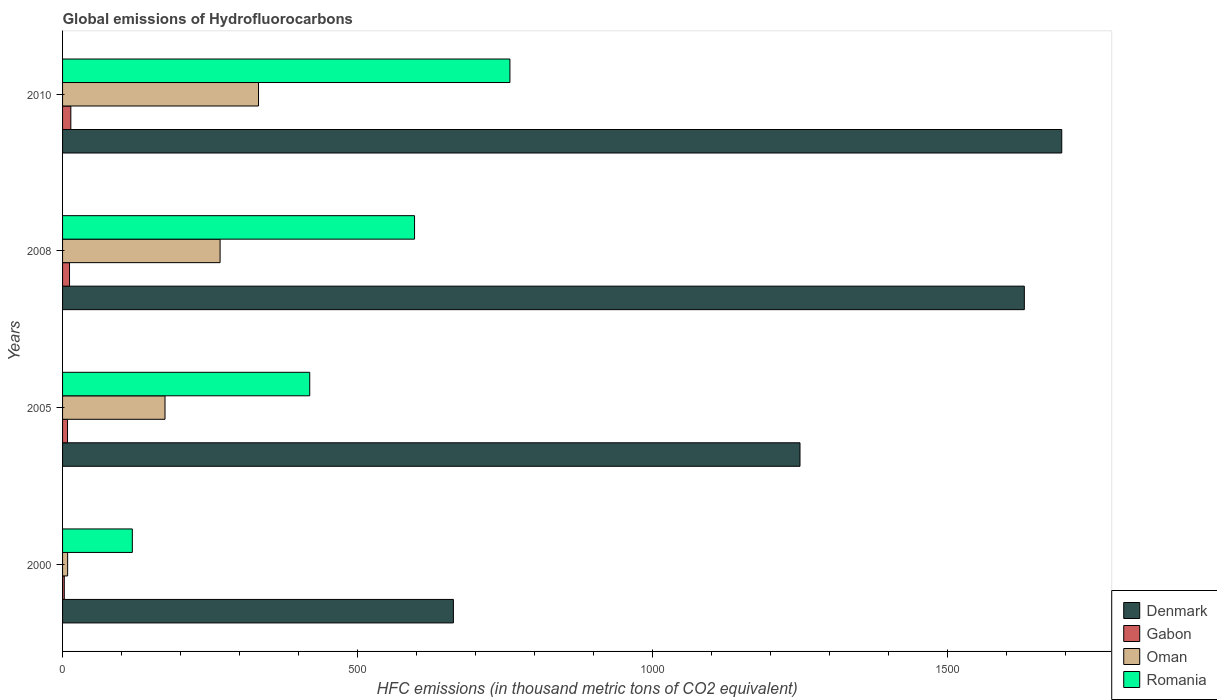Are the number of bars on each tick of the Y-axis equal?
Provide a short and direct response. Yes. How many bars are there on the 3rd tick from the bottom?
Your answer should be very brief. 4. What is the global emissions of Hydrofluorocarbons in Romania in 2000?
Offer a terse response. 118.2. Across all years, what is the maximum global emissions of Hydrofluorocarbons in Romania?
Provide a short and direct response. 758. Across all years, what is the minimum global emissions of Hydrofluorocarbons in Denmark?
Ensure brevity in your answer.  662.2. In which year was the global emissions of Hydrofluorocarbons in Gabon maximum?
Keep it short and to the point. 2010. In which year was the global emissions of Hydrofluorocarbons in Romania minimum?
Provide a succinct answer. 2000. What is the total global emissions of Hydrofluorocarbons in Denmark in the graph?
Ensure brevity in your answer.  5234.3. What is the difference between the global emissions of Hydrofluorocarbons in Gabon in 2000 and that in 2008?
Ensure brevity in your answer.  -8.9. What is the difference between the global emissions of Hydrofluorocarbons in Romania in 2010 and the global emissions of Hydrofluorocarbons in Gabon in 2005?
Provide a succinct answer. 749.6. What is the average global emissions of Hydrofluorocarbons in Oman per year?
Offer a very short reply. 195.27. In the year 2010, what is the difference between the global emissions of Hydrofluorocarbons in Denmark and global emissions of Hydrofluorocarbons in Romania?
Give a very brief answer. 935. What is the ratio of the global emissions of Hydrofluorocarbons in Oman in 2005 to that in 2008?
Your response must be concise. 0.65. Is the difference between the global emissions of Hydrofluorocarbons in Denmark in 2005 and 2010 greater than the difference between the global emissions of Hydrofluorocarbons in Romania in 2005 and 2010?
Provide a succinct answer. No. What is the difference between the highest and the second highest global emissions of Hydrofluorocarbons in Denmark?
Keep it short and to the point. 63.4. What is the difference between the highest and the lowest global emissions of Hydrofluorocarbons in Denmark?
Provide a short and direct response. 1030.8. In how many years, is the global emissions of Hydrofluorocarbons in Gabon greater than the average global emissions of Hydrofluorocarbons in Gabon taken over all years?
Give a very brief answer. 2. Is it the case that in every year, the sum of the global emissions of Hydrofluorocarbons in Denmark and global emissions of Hydrofluorocarbons in Oman is greater than the sum of global emissions of Hydrofluorocarbons in Gabon and global emissions of Hydrofluorocarbons in Romania?
Offer a very short reply. No. What does the 4th bar from the top in 2005 represents?
Provide a short and direct response. Denmark. What does the 3rd bar from the bottom in 2010 represents?
Make the answer very short. Oman. Is it the case that in every year, the sum of the global emissions of Hydrofluorocarbons in Oman and global emissions of Hydrofluorocarbons in Denmark is greater than the global emissions of Hydrofluorocarbons in Gabon?
Your response must be concise. Yes. How many bars are there?
Your answer should be compact. 16. How many years are there in the graph?
Offer a terse response. 4. What is the difference between two consecutive major ticks on the X-axis?
Make the answer very short. 500. Are the values on the major ticks of X-axis written in scientific E-notation?
Provide a succinct answer. No. Where does the legend appear in the graph?
Ensure brevity in your answer.  Bottom right. How many legend labels are there?
Make the answer very short. 4. What is the title of the graph?
Your answer should be very brief. Global emissions of Hydrofluorocarbons. What is the label or title of the X-axis?
Offer a very short reply. HFC emissions (in thousand metric tons of CO2 equivalent). What is the HFC emissions (in thousand metric tons of CO2 equivalent) of Denmark in 2000?
Keep it short and to the point. 662.2. What is the HFC emissions (in thousand metric tons of CO2 equivalent) of Romania in 2000?
Your response must be concise. 118.2. What is the HFC emissions (in thousand metric tons of CO2 equivalent) in Denmark in 2005?
Make the answer very short. 1249.5. What is the HFC emissions (in thousand metric tons of CO2 equivalent) in Gabon in 2005?
Your response must be concise. 8.4. What is the HFC emissions (in thousand metric tons of CO2 equivalent) in Oman in 2005?
Your answer should be very brief. 173.6. What is the HFC emissions (in thousand metric tons of CO2 equivalent) in Romania in 2005?
Your response must be concise. 418.8. What is the HFC emissions (in thousand metric tons of CO2 equivalent) of Denmark in 2008?
Keep it short and to the point. 1629.6. What is the HFC emissions (in thousand metric tons of CO2 equivalent) of Gabon in 2008?
Give a very brief answer. 11.8. What is the HFC emissions (in thousand metric tons of CO2 equivalent) in Oman in 2008?
Provide a short and direct response. 266.9. What is the HFC emissions (in thousand metric tons of CO2 equivalent) in Romania in 2008?
Provide a succinct answer. 596.4. What is the HFC emissions (in thousand metric tons of CO2 equivalent) of Denmark in 2010?
Your answer should be compact. 1693. What is the HFC emissions (in thousand metric tons of CO2 equivalent) of Oman in 2010?
Your answer should be very brief. 332. What is the HFC emissions (in thousand metric tons of CO2 equivalent) in Romania in 2010?
Your answer should be compact. 758. Across all years, what is the maximum HFC emissions (in thousand metric tons of CO2 equivalent) of Denmark?
Provide a short and direct response. 1693. Across all years, what is the maximum HFC emissions (in thousand metric tons of CO2 equivalent) of Gabon?
Keep it short and to the point. 14. Across all years, what is the maximum HFC emissions (in thousand metric tons of CO2 equivalent) of Oman?
Offer a very short reply. 332. Across all years, what is the maximum HFC emissions (in thousand metric tons of CO2 equivalent) in Romania?
Provide a succinct answer. 758. Across all years, what is the minimum HFC emissions (in thousand metric tons of CO2 equivalent) in Denmark?
Ensure brevity in your answer.  662.2. Across all years, what is the minimum HFC emissions (in thousand metric tons of CO2 equivalent) in Romania?
Give a very brief answer. 118.2. What is the total HFC emissions (in thousand metric tons of CO2 equivalent) in Denmark in the graph?
Offer a very short reply. 5234.3. What is the total HFC emissions (in thousand metric tons of CO2 equivalent) of Gabon in the graph?
Give a very brief answer. 37.1. What is the total HFC emissions (in thousand metric tons of CO2 equivalent) in Oman in the graph?
Ensure brevity in your answer.  781.1. What is the total HFC emissions (in thousand metric tons of CO2 equivalent) of Romania in the graph?
Keep it short and to the point. 1891.4. What is the difference between the HFC emissions (in thousand metric tons of CO2 equivalent) of Denmark in 2000 and that in 2005?
Provide a short and direct response. -587.3. What is the difference between the HFC emissions (in thousand metric tons of CO2 equivalent) in Oman in 2000 and that in 2005?
Offer a very short reply. -165. What is the difference between the HFC emissions (in thousand metric tons of CO2 equivalent) of Romania in 2000 and that in 2005?
Provide a short and direct response. -300.6. What is the difference between the HFC emissions (in thousand metric tons of CO2 equivalent) of Denmark in 2000 and that in 2008?
Make the answer very short. -967.4. What is the difference between the HFC emissions (in thousand metric tons of CO2 equivalent) in Gabon in 2000 and that in 2008?
Give a very brief answer. -8.9. What is the difference between the HFC emissions (in thousand metric tons of CO2 equivalent) of Oman in 2000 and that in 2008?
Make the answer very short. -258.3. What is the difference between the HFC emissions (in thousand metric tons of CO2 equivalent) in Romania in 2000 and that in 2008?
Make the answer very short. -478.2. What is the difference between the HFC emissions (in thousand metric tons of CO2 equivalent) in Denmark in 2000 and that in 2010?
Offer a terse response. -1030.8. What is the difference between the HFC emissions (in thousand metric tons of CO2 equivalent) of Oman in 2000 and that in 2010?
Ensure brevity in your answer.  -323.4. What is the difference between the HFC emissions (in thousand metric tons of CO2 equivalent) in Romania in 2000 and that in 2010?
Offer a terse response. -639.8. What is the difference between the HFC emissions (in thousand metric tons of CO2 equivalent) in Denmark in 2005 and that in 2008?
Your response must be concise. -380.1. What is the difference between the HFC emissions (in thousand metric tons of CO2 equivalent) of Gabon in 2005 and that in 2008?
Your response must be concise. -3.4. What is the difference between the HFC emissions (in thousand metric tons of CO2 equivalent) in Oman in 2005 and that in 2008?
Make the answer very short. -93.3. What is the difference between the HFC emissions (in thousand metric tons of CO2 equivalent) in Romania in 2005 and that in 2008?
Give a very brief answer. -177.6. What is the difference between the HFC emissions (in thousand metric tons of CO2 equivalent) of Denmark in 2005 and that in 2010?
Your response must be concise. -443.5. What is the difference between the HFC emissions (in thousand metric tons of CO2 equivalent) in Oman in 2005 and that in 2010?
Give a very brief answer. -158.4. What is the difference between the HFC emissions (in thousand metric tons of CO2 equivalent) in Romania in 2005 and that in 2010?
Provide a succinct answer. -339.2. What is the difference between the HFC emissions (in thousand metric tons of CO2 equivalent) in Denmark in 2008 and that in 2010?
Keep it short and to the point. -63.4. What is the difference between the HFC emissions (in thousand metric tons of CO2 equivalent) of Oman in 2008 and that in 2010?
Provide a succinct answer. -65.1. What is the difference between the HFC emissions (in thousand metric tons of CO2 equivalent) of Romania in 2008 and that in 2010?
Provide a succinct answer. -161.6. What is the difference between the HFC emissions (in thousand metric tons of CO2 equivalent) in Denmark in 2000 and the HFC emissions (in thousand metric tons of CO2 equivalent) in Gabon in 2005?
Provide a succinct answer. 653.8. What is the difference between the HFC emissions (in thousand metric tons of CO2 equivalent) in Denmark in 2000 and the HFC emissions (in thousand metric tons of CO2 equivalent) in Oman in 2005?
Provide a short and direct response. 488.6. What is the difference between the HFC emissions (in thousand metric tons of CO2 equivalent) in Denmark in 2000 and the HFC emissions (in thousand metric tons of CO2 equivalent) in Romania in 2005?
Provide a short and direct response. 243.4. What is the difference between the HFC emissions (in thousand metric tons of CO2 equivalent) of Gabon in 2000 and the HFC emissions (in thousand metric tons of CO2 equivalent) of Oman in 2005?
Provide a short and direct response. -170.7. What is the difference between the HFC emissions (in thousand metric tons of CO2 equivalent) in Gabon in 2000 and the HFC emissions (in thousand metric tons of CO2 equivalent) in Romania in 2005?
Your answer should be very brief. -415.9. What is the difference between the HFC emissions (in thousand metric tons of CO2 equivalent) of Oman in 2000 and the HFC emissions (in thousand metric tons of CO2 equivalent) of Romania in 2005?
Keep it short and to the point. -410.2. What is the difference between the HFC emissions (in thousand metric tons of CO2 equivalent) of Denmark in 2000 and the HFC emissions (in thousand metric tons of CO2 equivalent) of Gabon in 2008?
Give a very brief answer. 650.4. What is the difference between the HFC emissions (in thousand metric tons of CO2 equivalent) of Denmark in 2000 and the HFC emissions (in thousand metric tons of CO2 equivalent) of Oman in 2008?
Your answer should be compact. 395.3. What is the difference between the HFC emissions (in thousand metric tons of CO2 equivalent) of Denmark in 2000 and the HFC emissions (in thousand metric tons of CO2 equivalent) of Romania in 2008?
Offer a terse response. 65.8. What is the difference between the HFC emissions (in thousand metric tons of CO2 equivalent) of Gabon in 2000 and the HFC emissions (in thousand metric tons of CO2 equivalent) of Oman in 2008?
Ensure brevity in your answer.  -264. What is the difference between the HFC emissions (in thousand metric tons of CO2 equivalent) in Gabon in 2000 and the HFC emissions (in thousand metric tons of CO2 equivalent) in Romania in 2008?
Offer a very short reply. -593.5. What is the difference between the HFC emissions (in thousand metric tons of CO2 equivalent) in Oman in 2000 and the HFC emissions (in thousand metric tons of CO2 equivalent) in Romania in 2008?
Provide a succinct answer. -587.8. What is the difference between the HFC emissions (in thousand metric tons of CO2 equivalent) of Denmark in 2000 and the HFC emissions (in thousand metric tons of CO2 equivalent) of Gabon in 2010?
Provide a short and direct response. 648.2. What is the difference between the HFC emissions (in thousand metric tons of CO2 equivalent) of Denmark in 2000 and the HFC emissions (in thousand metric tons of CO2 equivalent) of Oman in 2010?
Make the answer very short. 330.2. What is the difference between the HFC emissions (in thousand metric tons of CO2 equivalent) in Denmark in 2000 and the HFC emissions (in thousand metric tons of CO2 equivalent) in Romania in 2010?
Ensure brevity in your answer.  -95.8. What is the difference between the HFC emissions (in thousand metric tons of CO2 equivalent) in Gabon in 2000 and the HFC emissions (in thousand metric tons of CO2 equivalent) in Oman in 2010?
Provide a succinct answer. -329.1. What is the difference between the HFC emissions (in thousand metric tons of CO2 equivalent) of Gabon in 2000 and the HFC emissions (in thousand metric tons of CO2 equivalent) of Romania in 2010?
Make the answer very short. -755.1. What is the difference between the HFC emissions (in thousand metric tons of CO2 equivalent) of Oman in 2000 and the HFC emissions (in thousand metric tons of CO2 equivalent) of Romania in 2010?
Provide a short and direct response. -749.4. What is the difference between the HFC emissions (in thousand metric tons of CO2 equivalent) in Denmark in 2005 and the HFC emissions (in thousand metric tons of CO2 equivalent) in Gabon in 2008?
Your answer should be compact. 1237.7. What is the difference between the HFC emissions (in thousand metric tons of CO2 equivalent) of Denmark in 2005 and the HFC emissions (in thousand metric tons of CO2 equivalent) of Oman in 2008?
Ensure brevity in your answer.  982.6. What is the difference between the HFC emissions (in thousand metric tons of CO2 equivalent) in Denmark in 2005 and the HFC emissions (in thousand metric tons of CO2 equivalent) in Romania in 2008?
Offer a terse response. 653.1. What is the difference between the HFC emissions (in thousand metric tons of CO2 equivalent) in Gabon in 2005 and the HFC emissions (in thousand metric tons of CO2 equivalent) in Oman in 2008?
Offer a very short reply. -258.5. What is the difference between the HFC emissions (in thousand metric tons of CO2 equivalent) in Gabon in 2005 and the HFC emissions (in thousand metric tons of CO2 equivalent) in Romania in 2008?
Keep it short and to the point. -588. What is the difference between the HFC emissions (in thousand metric tons of CO2 equivalent) in Oman in 2005 and the HFC emissions (in thousand metric tons of CO2 equivalent) in Romania in 2008?
Your answer should be compact. -422.8. What is the difference between the HFC emissions (in thousand metric tons of CO2 equivalent) of Denmark in 2005 and the HFC emissions (in thousand metric tons of CO2 equivalent) of Gabon in 2010?
Offer a terse response. 1235.5. What is the difference between the HFC emissions (in thousand metric tons of CO2 equivalent) in Denmark in 2005 and the HFC emissions (in thousand metric tons of CO2 equivalent) in Oman in 2010?
Your answer should be very brief. 917.5. What is the difference between the HFC emissions (in thousand metric tons of CO2 equivalent) in Denmark in 2005 and the HFC emissions (in thousand metric tons of CO2 equivalent) in Romania in 2010?
Ensure brevity in your answer.  491.5. What is the difference between the HFC emissions (in thousand metric tons of CO2 equivalent) of Gabon in 2005 and the HFC emissions (in thousand metric tons of CO2 equivalent) of Oman in 2010?
Your answer should be very brief. -323.6. What is the difference between the HFC emissions (in thousand metric tons of CO2 equivalent) in Gabon in 2005 and the HFC emissions (in thousand metric tons of CO2 equivalent) in Romania in 2010?
Offer a very short reply. -749.6. What is the difference between the HFC emissions (in thousand metric tons of CO2 equivalent) of Oman in 2005 and the HFC emissions (in thousand metric tons of CO2 equivalent) of Romania in 2010?
Make the answer very short. -584.4. What is the difference between the HFC emissions (in thousand metric tons of CO2 equivalent) in Denmark in 2008 and the HFC emissions (in thousand metric tons of CO2 equivalent) in Gabon in 2010?
Offer a terse response. 1615.6. What is the difference between the HFC emissions (in thousand metric tons of CO2 equivalent) in Denmark in 2008 and the HFC emissions (in thousand metric tons of CO2 equivalent) in Oman in 2010?
Make the answer very short. 1297.6. What is the difference between the HFC emissions (in thousand metric tons of CO2 equivalent) in Denmark in 2008 and the HFC emissions (in thousand metric tons of CO2 equivalent) in Romania in 2010?
Your response must be concise. 871.6. What is the difference between the HFC emissions (in thousand metric tons of CO2 equivalent) in Gabon in 2008 and the HFC emissions (in thousand metric tons of CO2 equivalent) in Oman in 2010?
Offer a terse response. -320.2. What is the difference between the HFC emissions (in thousand metric tons of CO2 equivalent) in Gabon in 2008 and the HFC emissions (in thousand metric tons of CO2 equivalent) in Romania in 2010?
Ensure brevity in your answer.  -746.2. What is the difference between the HFC emissions (in thousand metric tons of CO2 equivalent) of Oman in 2008 and the HFC emissions (in thousand metric tons of CO2 equivalent) of Romania in 2010?
Offer a terse response. -491.1. What is the average HFC emissions (in thousand metric tons of CO2 equivalent) of Denmark per year?
Ensure brevity in your answer.  1308.58. What is the average HFC emissions (in thousand metric tons of CO2 equivalent) of Gabon per year?
Make the answer very short. 9.28. What is the average HFC emissions (in thousand metric tons of CO2 equivalent) of Oman per year?
Keep it short and to the point. 195.28. What is the average HFC emissions (in thousand metric tons of CO2 equivalent) in Romania per year?
Provide a short and direct response. 472.85. In the year 2000, what is the difference between the HFC emissions (in thousand metric tons of CO2 equivalent) of Denmark and HFC emissions (in thousand metric tons of CO2 equivalent) of Gabon?
Your response must be concise. 659.3. In the year 2000, what is the difference between the HFC emissions (in thousand metric tons of CO2 equivalent) in Denmark and HFC emissions (in thousand metric tons of CO2 equivalent) in Oman?
Provide a succinct answer. 653.6. In the year 2000, what is the difference between the HFC emissions (in thousand metric tons of CO2 equivalent) of Denmark and HFC emissions (in thousand metric tons of CO2 equivalent) of Romania?
Ensure brevity in your answer.  544. In the year 2000, what is the difference between the HFC emissions (in thousand metric tons of CO2 equivalent) of Gabon and HFC emissions (in thousand metric tons of CO2 equivalent) of Oman?
Your answer should be compact. -5.7. In the year 2000, what is the difference between the HFC emissions (in thousand metric tons of CO2 equivalent) in Gabon and HFC emissions (in thousand metric tons of CO2 equivalent) in Romania?
Provide a short and direct response. -115.3. In the year 2000, what is the difference between the HFC emissions (in thousand metric tons of CO2 equivalent) of Oman and HFC emissions (in thousand metric tons of CO2 equivalent) of Romania?
Make the answer very short. -109.6. In the year 2005, what is the difference between the HFC emissions (in thousand metric tons of CO2 equivalent) in Denmark and HFC emissions (in thousand metric tons of CO2 equivalent) in Gabon?
Your answer should be very brief. 1241.1. In the year 2005, what is the difference between the HFC emissions (in thousand metric tons of CO2 equivalent) in Denmark and HFC emissions (in thousand metric tons of CO2 equivalent) in Oman?
Ensure brevity in your answer.  1075.9. In the year 2005, what is the difference between the HFC emissions (in thousand metric tons of CO2 equivalent) of Denmark and HFC emissions (in thousand metric tons of CO2 equivalent) of Romania?
Provide a short and direct response. 830.7. In the year 2005, what is the difference between the HFC emissions (in thousand metric tons of CO2 equivalent) of Gabon and HFC emissions (in thousand metric tons of CO2 equivalent) of Oman?
Ensure brevity in your answer.  -165.2. In the year 2005, what is the difference between the HFC emissions (in thousand metric tons of CO2 equivalent) in Gabon and HFC emissions (in thousand metric tons of CO2 equivalent) in Romania?
Provide a short and direct response. -410.4. In the year 2005, what is the difference between the HFC emissions (in thousand metric tons of CO2 equivalent) of Oman and HFC emissions (in thousand metric tons of CO2 equivalent) of Romania?
Provide a succinct answer. -245.2. In the year 2008, what is the difference between the HFC emissions (in thousand metric tons of CO2 equivalent) of Denmark and HFC emissions (in thousand metric tons of CO2 equivalent) of Gabon?
Offer a terse response. 1617.8. In the year 2008, what is the difference between the HFC emissions (in thousand metric tons of CO2 equivalent) of Denmark and HFC emissions (in thousand metric tons of CO2 equivalent) of Oman?
Your answer should be very brief. 1362.7. In the year 2008, what is the difference between the HFC emissions (in thousand metric tons of CO2 equivalent) in Denmark and HFC emissions (in thousand metric tons of CO2 equivalent) in Romania?
Provide a succinct answer. 1033.2. In the year 2008, what is the difference between the HFC emissions (in thousand metric tons of CO2 equivalent) in Gabon and HFC emissions (in thousand metric tons of CO2 equivalent) in Oman?
Your answer should be very brief. -255.1. In the year 2008, what is the difference between the HFC emissions (in thousand metric tons of CO2 equivalent) in Gabon and HFC emissions (in thousand metric tons of CO2 equivalent) in Romania?
Your answer should be very brief. -584.6. In the year 2008, what is the difference between the HFC emissions (in thousand metric tons of CO2 equivalent) in Oman and HFC emissions (in thousand metric tons of CO2 equivalent) in Romania?
Your answer should be compact. -329.5. In the year 2010, what is the difference between the HFC emissions (in thousand metric tons of CO2 equivalent) of Denmark and HFC emissions (in thousand metric tons of CO2 equivalent) of Gabon?
Your answer should be compact. 1679. In the year 2010, what is the difference between the HFC emissions (in thousand metric tons of CO2 equivalent) of Denmark and HFC emissions (in thousand metric tons of CO2 equivalent) of Oman?
Provide a succinct answer. 1361. In the year 2010, what is the difference between the HFC emissions (in thousand metric tons of CO2 equivalent) in Denmark and HFC emissions (in thousand metric tons of CO2 equivalent) in Romania?
Your answer should be compact. 935. In the year 2010, what is the difference between the HFC emissions (in thousand metric tons of CO2 equivalent) of Gabon and HFC emissions (in thousand metric tons of CO2 equivalent) of Oman?
Ensure brevity in your answer.  -318. In the year 2010, what is the difference between the HFC emissions (in thousand metric tons of CO2 equivalent) of Gabon and HFC emissions (in thousand metric tons of CO2 equivalent) of Romania?
Your response must be concise. -744. In the year 2010, what is the difference between the HFC emissions (in thousand metric tons of CO2 equivalent) of Oman and HFC emissions (in thousand metric tons of CO2 equivalent) of Romania?
Make the answer very short. -426. What is the ratio of the HFC emissions (in thousand metric tons of CO2 equivalent) in Denmark in 2000 to that in 2005?
Provide a short and direct response. 0.53. What is the ratio of the HFC emissions (in thousand metric tons of CO2 equivalent) of Gabon in 2000 to that in 2005?
Your answer should be very brief. 0.35. What is the ratio of the HFC emissions (in thousand metric tons of CO2 equivalent) of Oman in 2000 to that in 2005?
Your answer should be compact. 0.05. What is the ratio of the HFC emissions (in thousand metric tons of CO2 equivalent) of Romania in 2000 to that in 2005?
Give a very brief answer. 0.28. What is the ratio of the HFC emissions (in thousand metric tons of CO2 equivalent) in Denmark in 2000 to that in 2008?
Keep it short and to the point. 0.41. What is the ratio of the HFC emissions (in thousand metric tons of CO2 equivalent) in Gabon in 2000 to that in 2008?
Offer a terse response. 0.25. What is the ratio of the HFC emissions (in thousand metric tons of CO2 equivalent) in Oman in 2000 to that in 2008?
Offer a terse response. 0.03. What is the ratio of the HFC emissions (in thousand metric tons of CO2 equivalent) in Romania in 2000 to that in 2008?
Make the answer very short. 0.2. What is the ratio of the HFC emissions (in thousand metric tons of CO2 equivalent) in Denmark in 2000 to that in 2010?
Your answer should be very brief. 0.39. What is the ratio of the HFC emissions (in thousand metric tons of CO2 equivalent) in Gabon in 2000 to that in 2010?
Keep it short and to the point. 0.21. What is the ratio of the HFC emissions (in thousand metric tons of CO2 equivalent) of Oman in 2000 to that in 2010?
Give a very brief answer. 0.03. What is the ratio of the HFC emissions (in thousand metric tons of CO2 equivalent) of Romania in 2000 to that in 2010?
Your answer should be compact. 0.16. What is the ratio of the HFC emissions (in thousand metric tons of CO2 equivalent) in Denmark in 2005 to that in 2008?
Offer a very short reply. 0.77. What is the ratio of the HFC emissions (in thousand metric tons of CO2 equivalent) in Gabon in 2005 to that in 2008?
Your answer should be very brief. 0.71. What is the ratio of the HFC emissions (in thousand metric tons of CO2 equivalent) in Oman in 2005 to that in 2008?
Ensure brevity in your answer.  0.65. What is the ratio of the HFC emissions (in thousand metric tons of CO2 equivalent) of Romania in 2005 to that in 2008?
Ensure brevity in your answer.  0.7. What is the ratio of the HFC emissions (in thousand metric tons of CO2 equivalent) in Denmark in 2005 to that in 2010?
Keep it short and to the point. 0.74. What is the ratio of the HFC emissions (in thousand metric tons of CO2 equivalent) of Oman in 2005 to that in 2010?
Make the answer very short. 0.52. What is the ratio of the HFC emissions (in thousand metric tons of CO2 equivalent) of Romania in 2005 to that in 2010?
Provide a short and direct response. 0.55. What is the ratio of the HFC emissions (in thousand metric tons of CO2 equivalent) in Denmark in 2008 to that in 2010?
Your answer should be very brief. 0.96. What is the ratio of the HFC emissions (in thousand metric tons of CO2 equivalent) of Gabon in 2008 to that in 2010?
Your answer should be very brief. 0.84. What is the ratio of the HFC emissions (in thousand metric tons of CO2 equivalent) in Oman in 2008 to that in 2010?
Make the answer very short. 0.8. What is the ratio of the HFC emissions (in thousand metric tons of CO2 equivalent) of Romania in 2008 to that in 2010?
Your answer should be compact. 0.79. What is the difference between the highest and the second highest HFC emissions (in thousand metric tons of CO2 equivalent) in Denmark?
Give a very brief answer. 63.4. What is the difference between the highest and the second highest HFC emissions (in thousand metric tons of CO2 equivalent) in Gabon?
Provide a short and direct response. 2.2. What is the difference between the highest and the second highest HFC emissions (in thousand metric tons of CO2 equivalent) of Oman?
Provide a short and direct response. 65.1. What is the difference between the highest and the second highest HFC emissions (in thousand metric tons of CO2 equivalent) in Romania?
Your answer should be compact. 161.6. What is the difference between the highest and the lowest HFC emissions (in thousand metric tons of CO2 equivalent) of Denmark?
Keep it short and to the point. 1030.8. What is the difference between the highest and the lowest HFC emissions (in thousand metric tons of CO2 equivalent) of Gabon?
Your answer should be compact. 11.1. What is the difference between the highest and the lowest HFC emissions (in thousand metric tons of CO2 equivalent) in Oman?
Your answer should be compact. 323.4. What is the difference between the highest and the lowest HFC emissions (in thousand metric tons of CO2 equivalent) of Romania?
Keep it short and to the point. 639.8. 